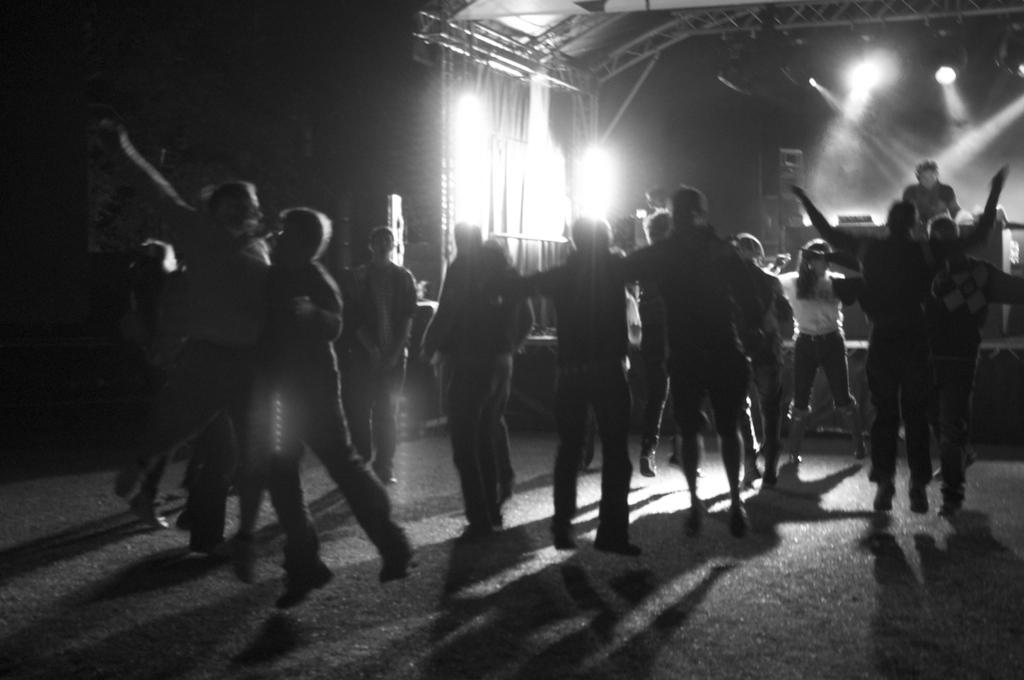What are the persons in the image doing? The persons in the image are dancing on a floor. How are the persons dressed? The persons are in different color dresses. What can be seen in the background of the image? There is a person on a stage, lights, and a roof visible in the background. What type of box can be seen on the street in the image? There is no box or street present in the image; it features persons dancing on a floor with a background that includes a person on a stage, lights, and a roof. 